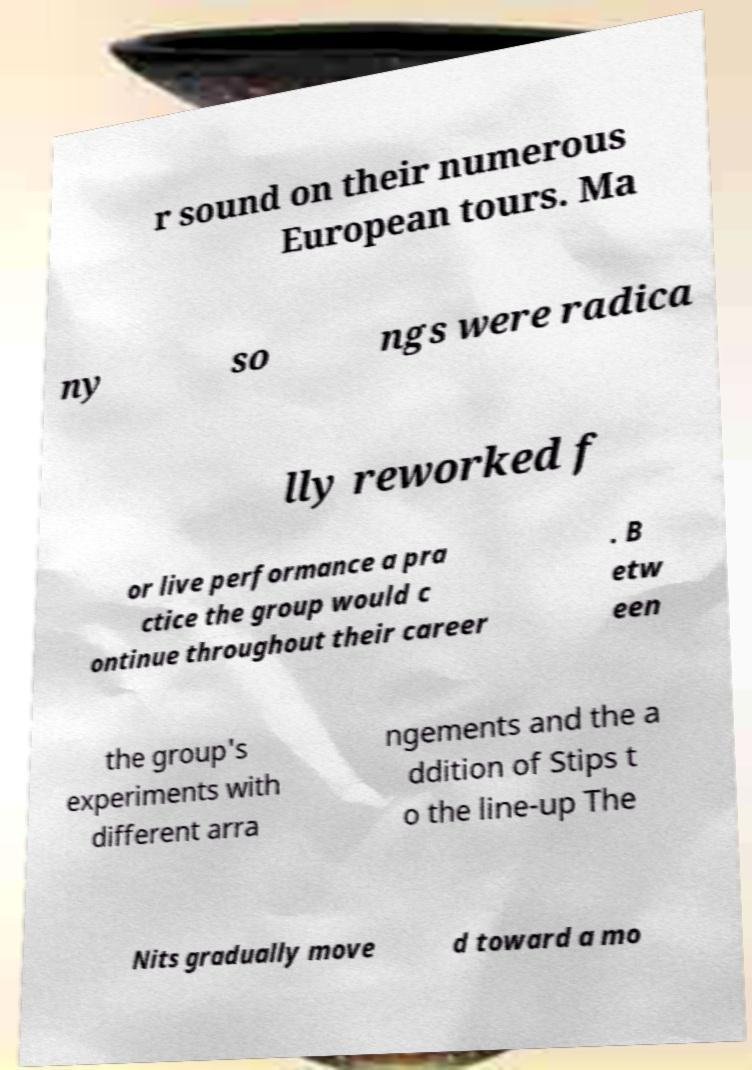Could you assist in decoding the text presented in this image and type it out clearly? r sound on their numerous European tours. Ma ny so ngs were radica lly reworked f or live performance a pra ctice the group would c ontinue throughout their career . B etw een the group's experiments with different arra ngements and the a ddition of Stips t o the line-up The Nits gradually move d toward a mo 